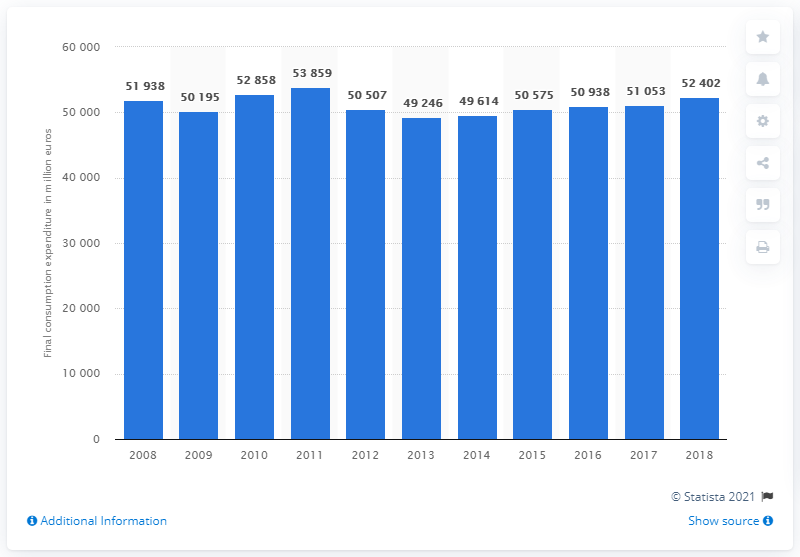Give some essential details in this illustration. In 2018, Italian households spent an estimated 51,053 million euros on clothing. The fluctuation in the total consumption expenditure on clothing by Italian households between 2008 and 2018 was approximately 51,053 million euros. 